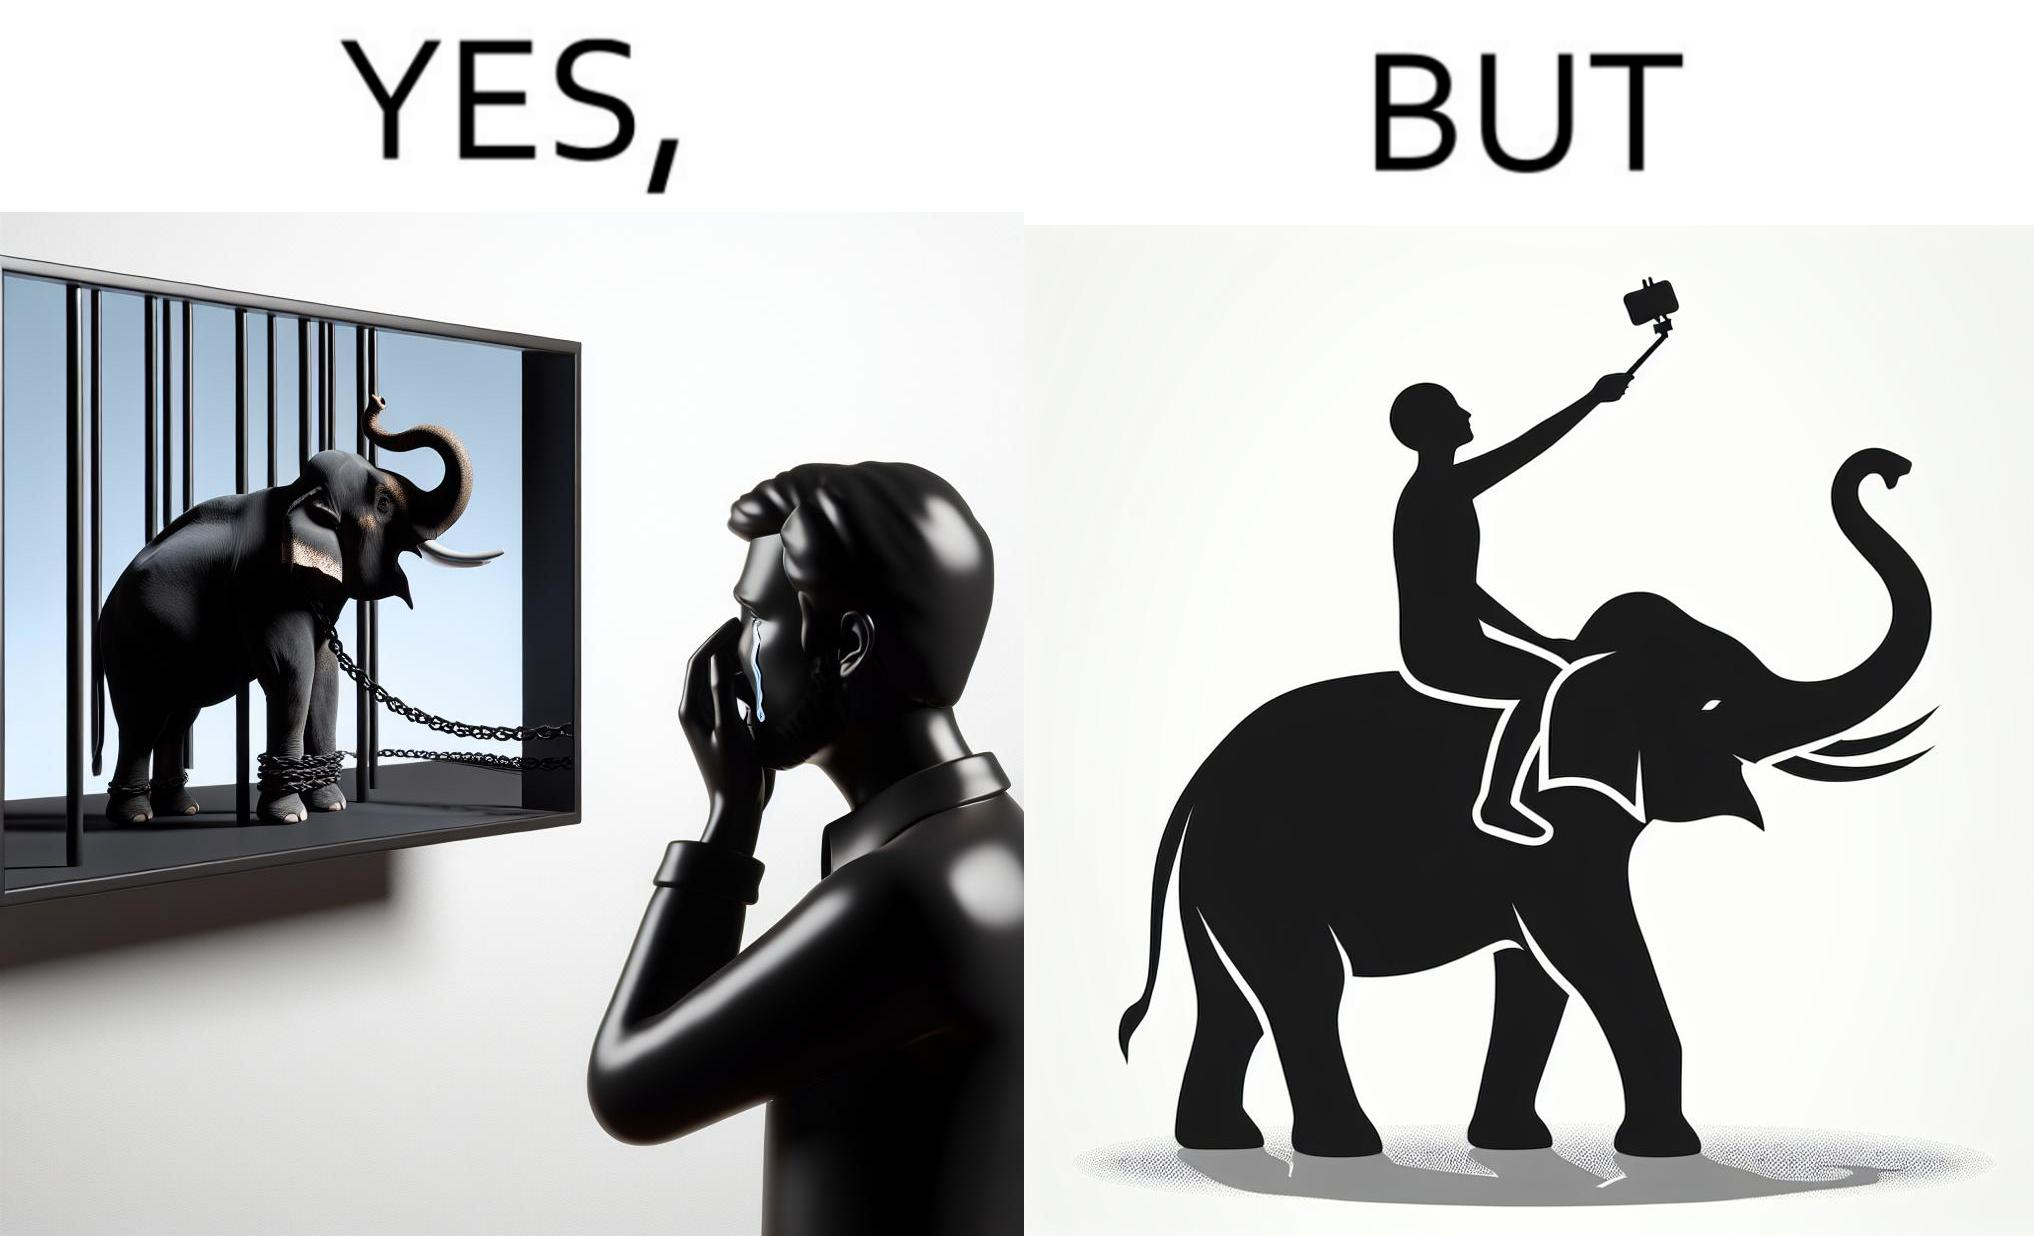Does this image contain satire or humor? Yes, this image is satirical. 